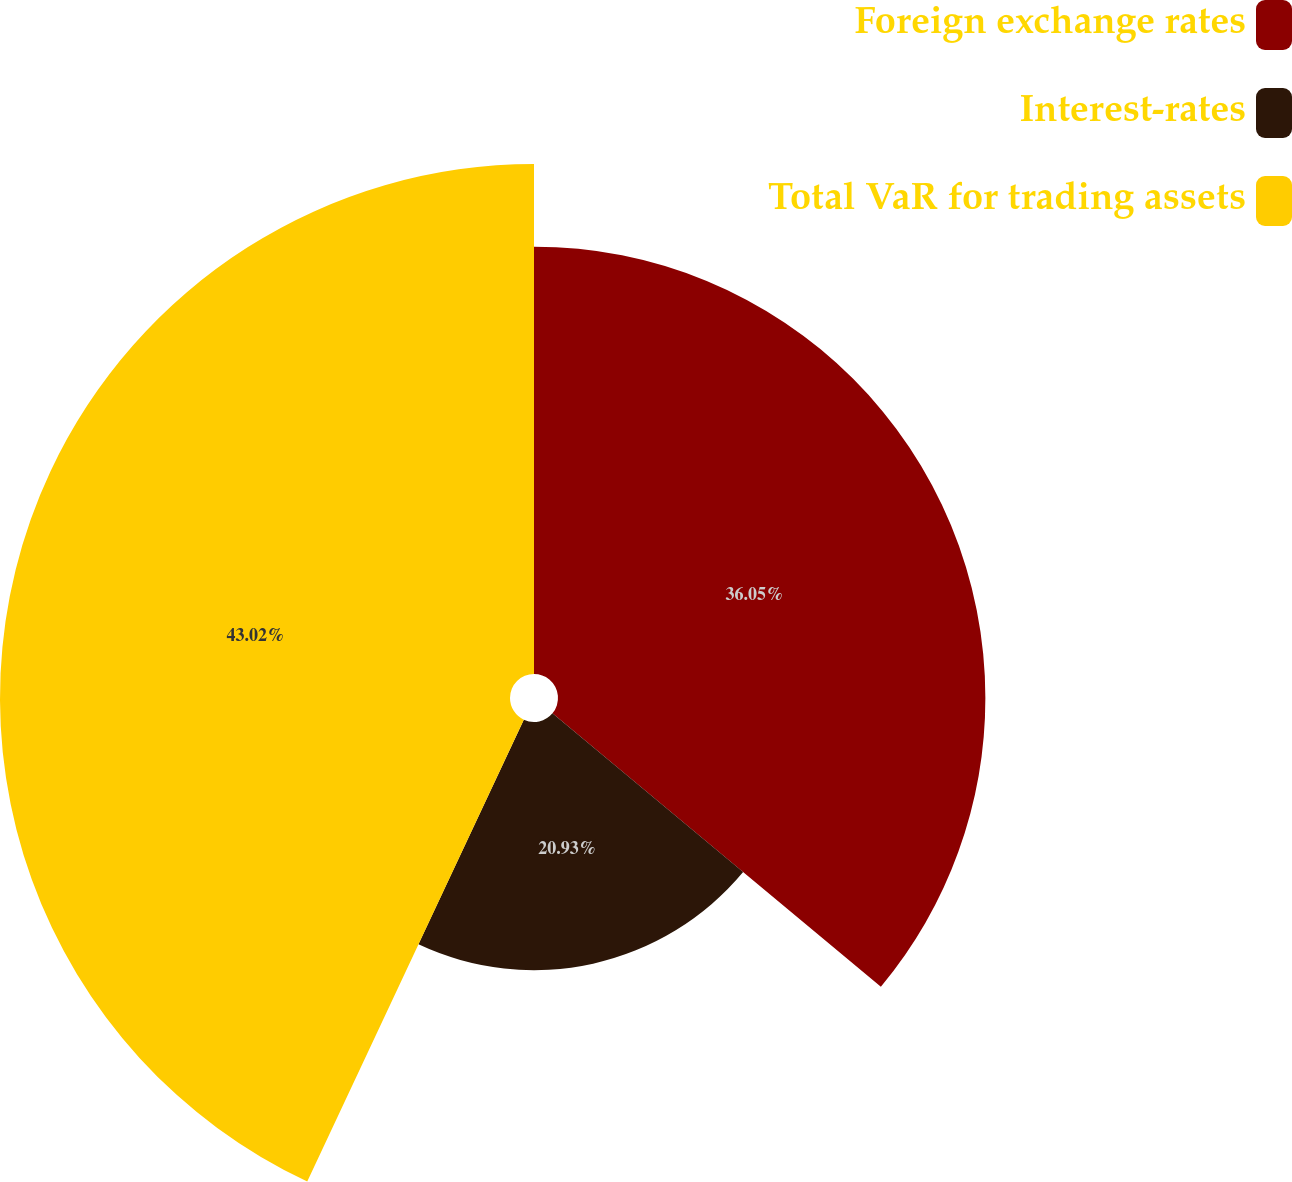Convert chart. <chart><loc_0><loc_0><loc_500><loc_500><pie_chart><fcel>Foreign exchange rates<fcel>Interest-rates<fcel>Total VaR for trading assets<nl><fcel>36.05%<fcel>20.93%<fcel>43.02%<nl></chart> 